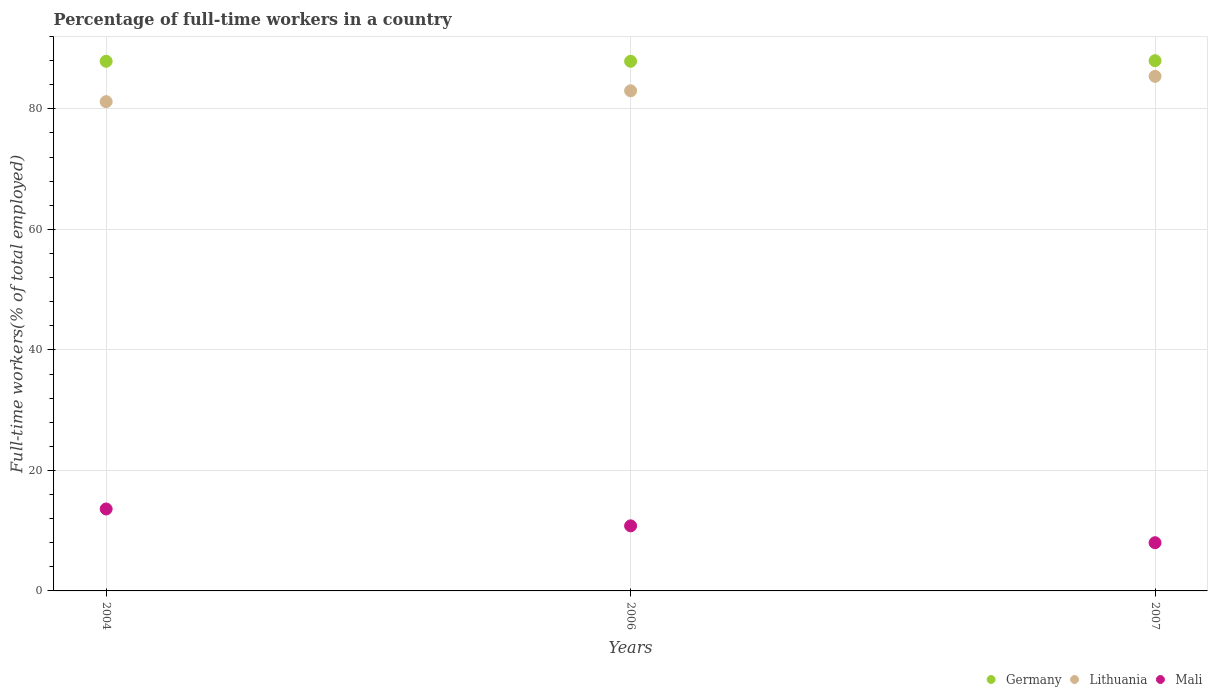How many different coloured dotlines are there?
Keep it short and to the point. 3. Is the number of dotlines equal to the number of legend labels?
Offer a terse response. Yes. What is the percentage of full-time workers in Lithuania in 2006?
Your answer should be compact. 83. Across all years, what is the maximum percentage of full-time workers in Mali?
Make the answer very short. 13.6. Across all years, what is the minimum percentage of full-time workers in Germany?
Provide a succinct answer. 87.9. What is the total percentage of full-time workers in Mali in the graph?
Provide a short and direct response. 32.4. What is the difference between the percentage of full-time workers in Lithuania in 2004 and that in 2007?
Keep it short and to the point. -4.2. What is the difference between the percentage of full-time workers in Germany in 2004 and the percentage of full-time workers in Lithuania in 2007?
Provide a short and direct response. 2.5. What is the average percentage of full-time workers in Germany per year?
Give a very brief answer. 87.93. In the year 2007, what is the difference between the percentage of full-time workers in Lithuania and percentage of full-time workers in Mali?
Give a very brief answer. 77.4. In how many years, is the percentage of full-time workers in Germany greater than 8 %?
Your answer should be very brief. 3. What is the ratio of the percentage of full-time workers in Germany in 2004 to that in 2006?
Your response must be concise. 1. Is the percentage of full-time workers in Germany in 2006 less than that in 2007?
Your answer should be very brief. Yes. What is the difference between the highest and the second highest percentage of full-time workers in Germany?
Provide a short and direct response. 0.1. What is the difference between the highest and the lowest percentage of full-time workers in Lithuania?
Ensure brevity in your answer.  4.2. Does the percentage of full-time workers in Germany monotonically increase over the years?
Make the answer very short. No. Is the percentage of full-time workers in Mali strictly greater than the percentage of full-time workers in Germany over the years?
Keep it short and to the point. No. Is the percentage of full-time workers in Lithuania strictly less than the percentage of full-time workers in Germany over the years?
Keep it short and to the point. Yes. How many dotlines are there?
Provide a succinct answer. 3. What is the difference between two consecutive major ticks on the Y-axis?
Your answer should be very brief. 20. Does the graph contain grids?
Provide a short and direct response. Yes. Where does the legend appear in the graph?
Give a very brief answer. Bottom right. How many legend labels are there?
Your answer should be compact. 3. How are the legend labels stacked?
Your response must be concise. Horizontal. What is the title of the graph?
Your response must be concise. Percentage of full-time workers in a country. What is the label or title of the X-axis?
Offer a very short reply. Years. What is the label or title of the Y-axis?
Ensure brevity in your answer.  Full-time workers(% of total employed). What is the Full-time workers(% of total employed) of Germany in 2004?
Ensure brevity in your answer.  87.9. What is the Full-time workers(% of total employed) of Lithuania in 2004?
Provide a short and direct response. 81.2. What is the Full-time workers(% of total employed) in Mali in 2004?
Offer a very short reply. 13.6. What is the Full-time workers(% of total employed) of Germany in 2006?
Keep it short and to the point. 87.9. What is the Full-time workers(% of total employed) in Mali in 2006?
Give a very brief answer. 10.8. What is the Full-time workers(% of total employed) in Germany in 2007?
Provide a short and direct response. 88. What is the Full-time workers(% of total employed) of Lithuania in 2007?
Your response must be concise. 85.4. Across all years, what is the maximum Full-time workers(% of total employed) in Germany?
Offer a terse response. 88. Across all years, what is the maximum Full-time workers(% of total employed) of Lithuania?
Your answer should be very brief. 85.4. Across all years, what is the maximum Full-time workers(% of total employed) of Mali?
Your answer should be compact. 13.6. Across all years, what is the minimum Full-time workers(% of total employed) in Germany?
Ensure brevity in your answer.  87.9. Across all years, what is the minimum Full-time workers(% of total employed) of Lithuania?
Offer a terse response. 81.2. What is the total Full-time workers(% of total employed) in Germany in the graph?
Your response must be concise. 263.8. What is the total Full-time workers(% of total employed) of Lithuania in the graph?
Provide a succinct answer. 249.6. What is the total Full-time workers(% of total employed) of Mali in the graph?
Your answer should be compact. 32.4. What is the difference between the Full-time workers(% of total employed) in Germany in 2004 and that in 2006?
Provide a succinct answer. 0. What is the difference between the Full-time workers(% of total employed) of Lithuania in 2004 and that in 2006?
Your answer should be very brief. -1.8. What is the difference between the Full-time workers(% of total employed) of Germany in 2004 and that in 2007?
Your response must be concise. -0.1. What is the difference between the Full-time workers(% of total employed) of Lithuania in 2004 and that in 2007?
Your answer should be very brief. -4.2. What is the difference between the Full-time workers(% of total employed) of Lithuania in 2006 and that in 2007?
Keep it short and to the point. -2.4. What is the difference between the Full-time workers(% of total employed) of Germany in 2004 and the Full-time workers(% of total employed) of Mali in 2006?
Give a very brief answer. 77.1. What is the difference between the Full-time workers(% of total employed) in Lithuania in 2004 and the Full-time workers(% of total employed) in Mali in 2006?
Make the answer very short. 70.4. What is the difference between the Full-time workers(% of total employed) of Germany in 2004 and the Full-time workers(% of total employed) of Lithuania in 2007?
Your answer should be compact. 2.5. What is the difference between the Full-time workers(% of total employed) of Germany in 2004 and the Full-time workers(% of total employed) of Mali in 2007?
Provide a succinct answer. 79.9. What is the difference between the Full-time workers(% of total employed) in Lithuania in 2004 and the Full-time workers(% of total employed) in Mali in 2007?
Make the answer very short. 73.2. What is the difference between the Full-time workers(% of total employed) of Germany in 2006 and the Full-time workers(% of total employed) of Lithuania in 2007?
Your answer should be very brief. 2.5. What is the difference between the Full-time workers(% of total employed) of Germany in 2006 and the Full-time workers(% of total employed) of Mali in 2007?
Give a very brief answer. 79.9. What is the difference between the Full-time workers(% of total employed) in Lithuania in 2006 and the Full-time workers(% of total employed) in Mali in 2007?
Give a very brief answer. 75. What is the average Full-time workers(% of total employed) in Germany per year?
Provide a short and direct response. 87.93. What is the average Full-time workers(% of total employed) in Lithuania per year?
Give a very brief answer. 83.2. What is the average Full-time workers(% of total employed) in Mali per year?
Your answer should be very brief. 10.8. In the year 2004, what is the difference between the Full-time workers(% of total employed) of Germany and Full-time workers(% of total employed) of Lithuania?
Give a very brief answer. 6.7. In the year 2004, what is the difference between the Full-time workers(% of total employed) of Germany and Full-time workers(% of total employed) of Mali?
Provide a succinct answer. 74.3. In the year 2004, what is the difference between the Full-time workers(% of total employed) of Lithuania and Full-time workers(% of total employed) of Mali?
Your answer should be compact. 67.6. In the year 2006, what is the difference between the Full-time workers(% of total employed) in Germany and Full-time workers(% of total employed) in Lithuania?
Your answer should be compact. 4.9. In the year 2006, what is the difference between the Full-time workers(% of total employed) in Germany and Full-time workers(% of total employed) in Mali?
Your answer should be very brief. 77.1. In the year 2006, what is the difference between the Full-time workers(% of total employed) of Lithuania and Full-time workers(% of total employed) of Mali?
Your answer should be very brief. 72.2. In the year 2007, what is the difference between the Full-time workers(% of total employed) of Germany and Full-time workers(% of total employed) of Lithuania?
Give a very brief answer. 2.6. In the year 2007, what is the difference between the Full-time workers(% of total employed) in Germany and Full-time workers(% of total employed) in Mali?
Provide a short and direct response. 80. In the year 2007, what is the difference between the Full-time workers(% of total employed) of Lithuania and Full-time workers(% of total employed) of Mali?
Offer a very short reply. 77.4. What is the ratio of the Full-time workers(% of total employed) in Germany in 2004 to that in 2006?
Your response must be concise. 1. What is the ratio of the Full-time workers(% of total employed) of Lithuania in 2004 to that in 2006?
Provide a succinct answer. 0.98. What is the ratio of the Full-time workers(% of total employed) of Mali in 2004 to that in 2006?
Ensure brevity in your answer.  1.26. What is the ratio of the Full-time workers(% of total employed) of Germany in 2004 to that in 2007?
Your answer should be compact. 1. What is the ratio of the Full-time workers(% of total employed) of Lithuania in 2004 to that in 2007?
Provide a succinct answer. 0.95. What is the ratio of the Full-time workers(% of total employed) of Germany in 2006 to that in 2007?
Offer a terse response. 1. What is the ratio of the Full-time workers(% of total employed) of Lithuania in 2006 to that in 2007?
Your response must be concise. 0.97. What is the ratio of the Full-time workers(% of total employed) in Mali in 2006 to that in 2007?
Your response must be concise. 1.35. What is the difference between the highest and the second highest Full-time workers(% of total employed) of Mali?
Your answer should be very brief. 2.8. What is the difference between the highest and the lowest Full-time workers(% of total employed) in Mali?
Your answer should be compact. 5.6. 